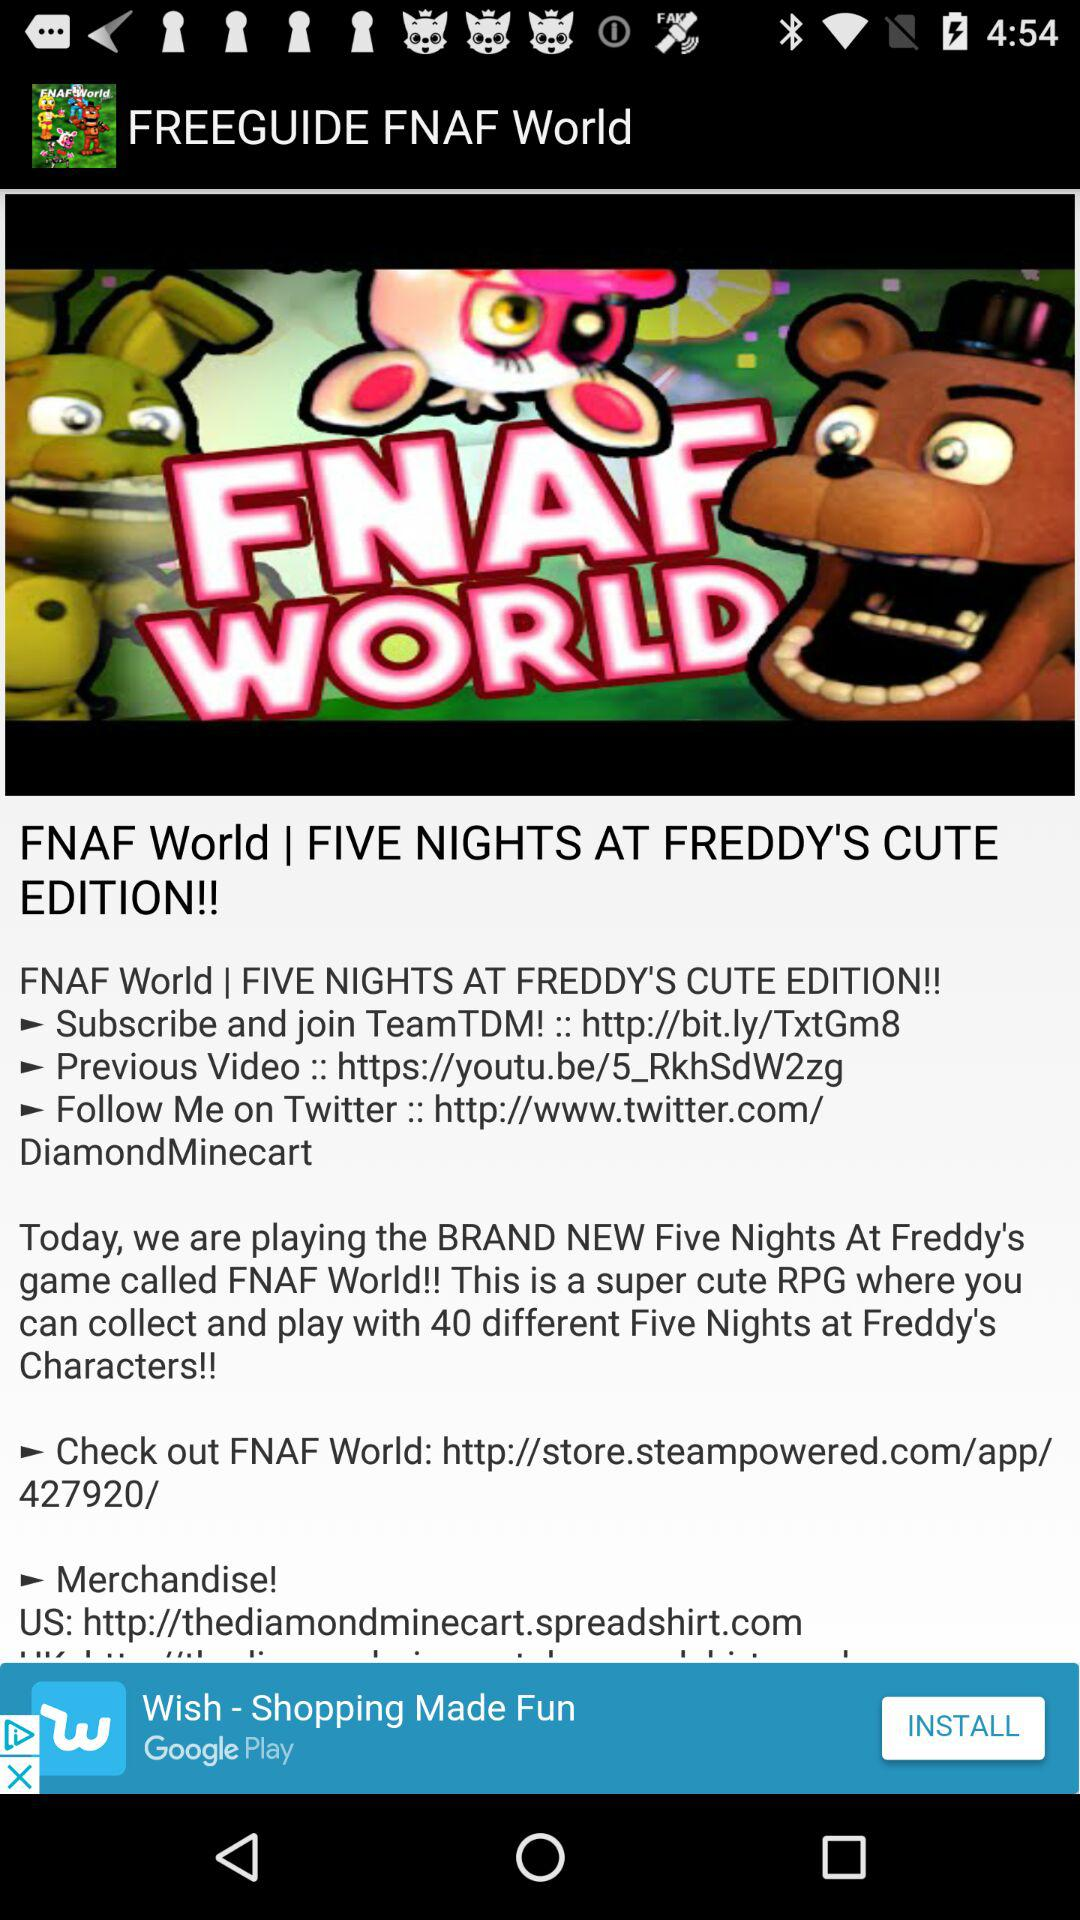How many different characters does the "Five Nights at Freddy's" game have? The "Five Nights at Freddy's" game has 40 different characters. 